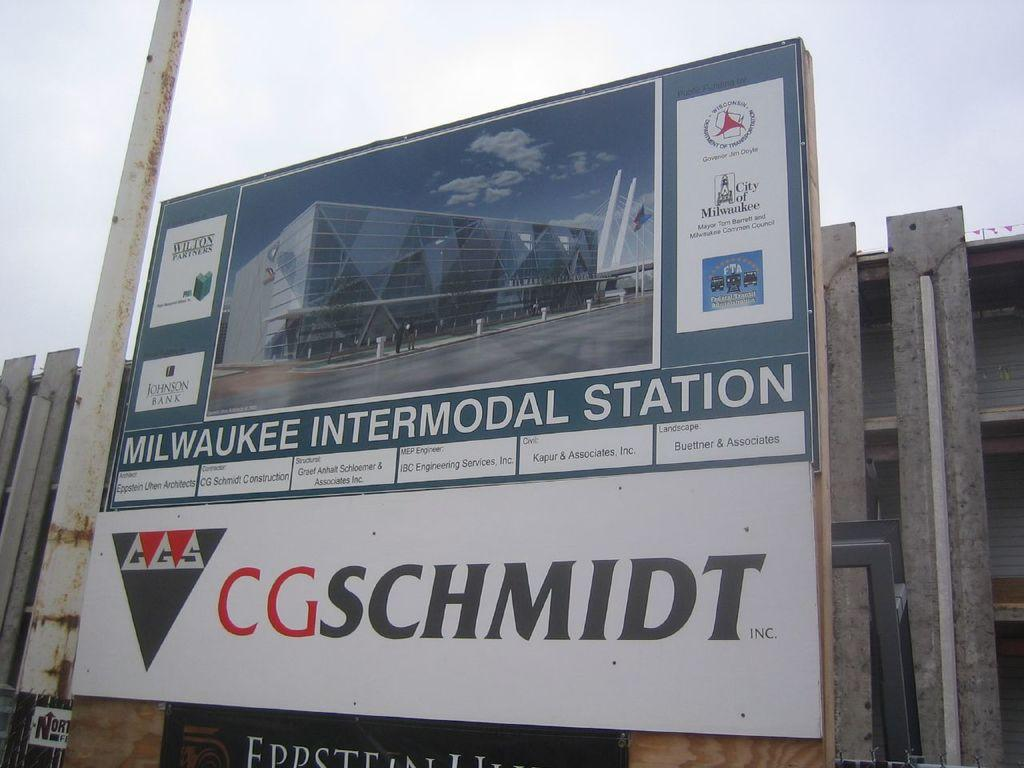<image>
Share a concise interpretation of the image provided. A Milwaukee Intermodal Station by CG Schmidt is advertised on a billboard. 